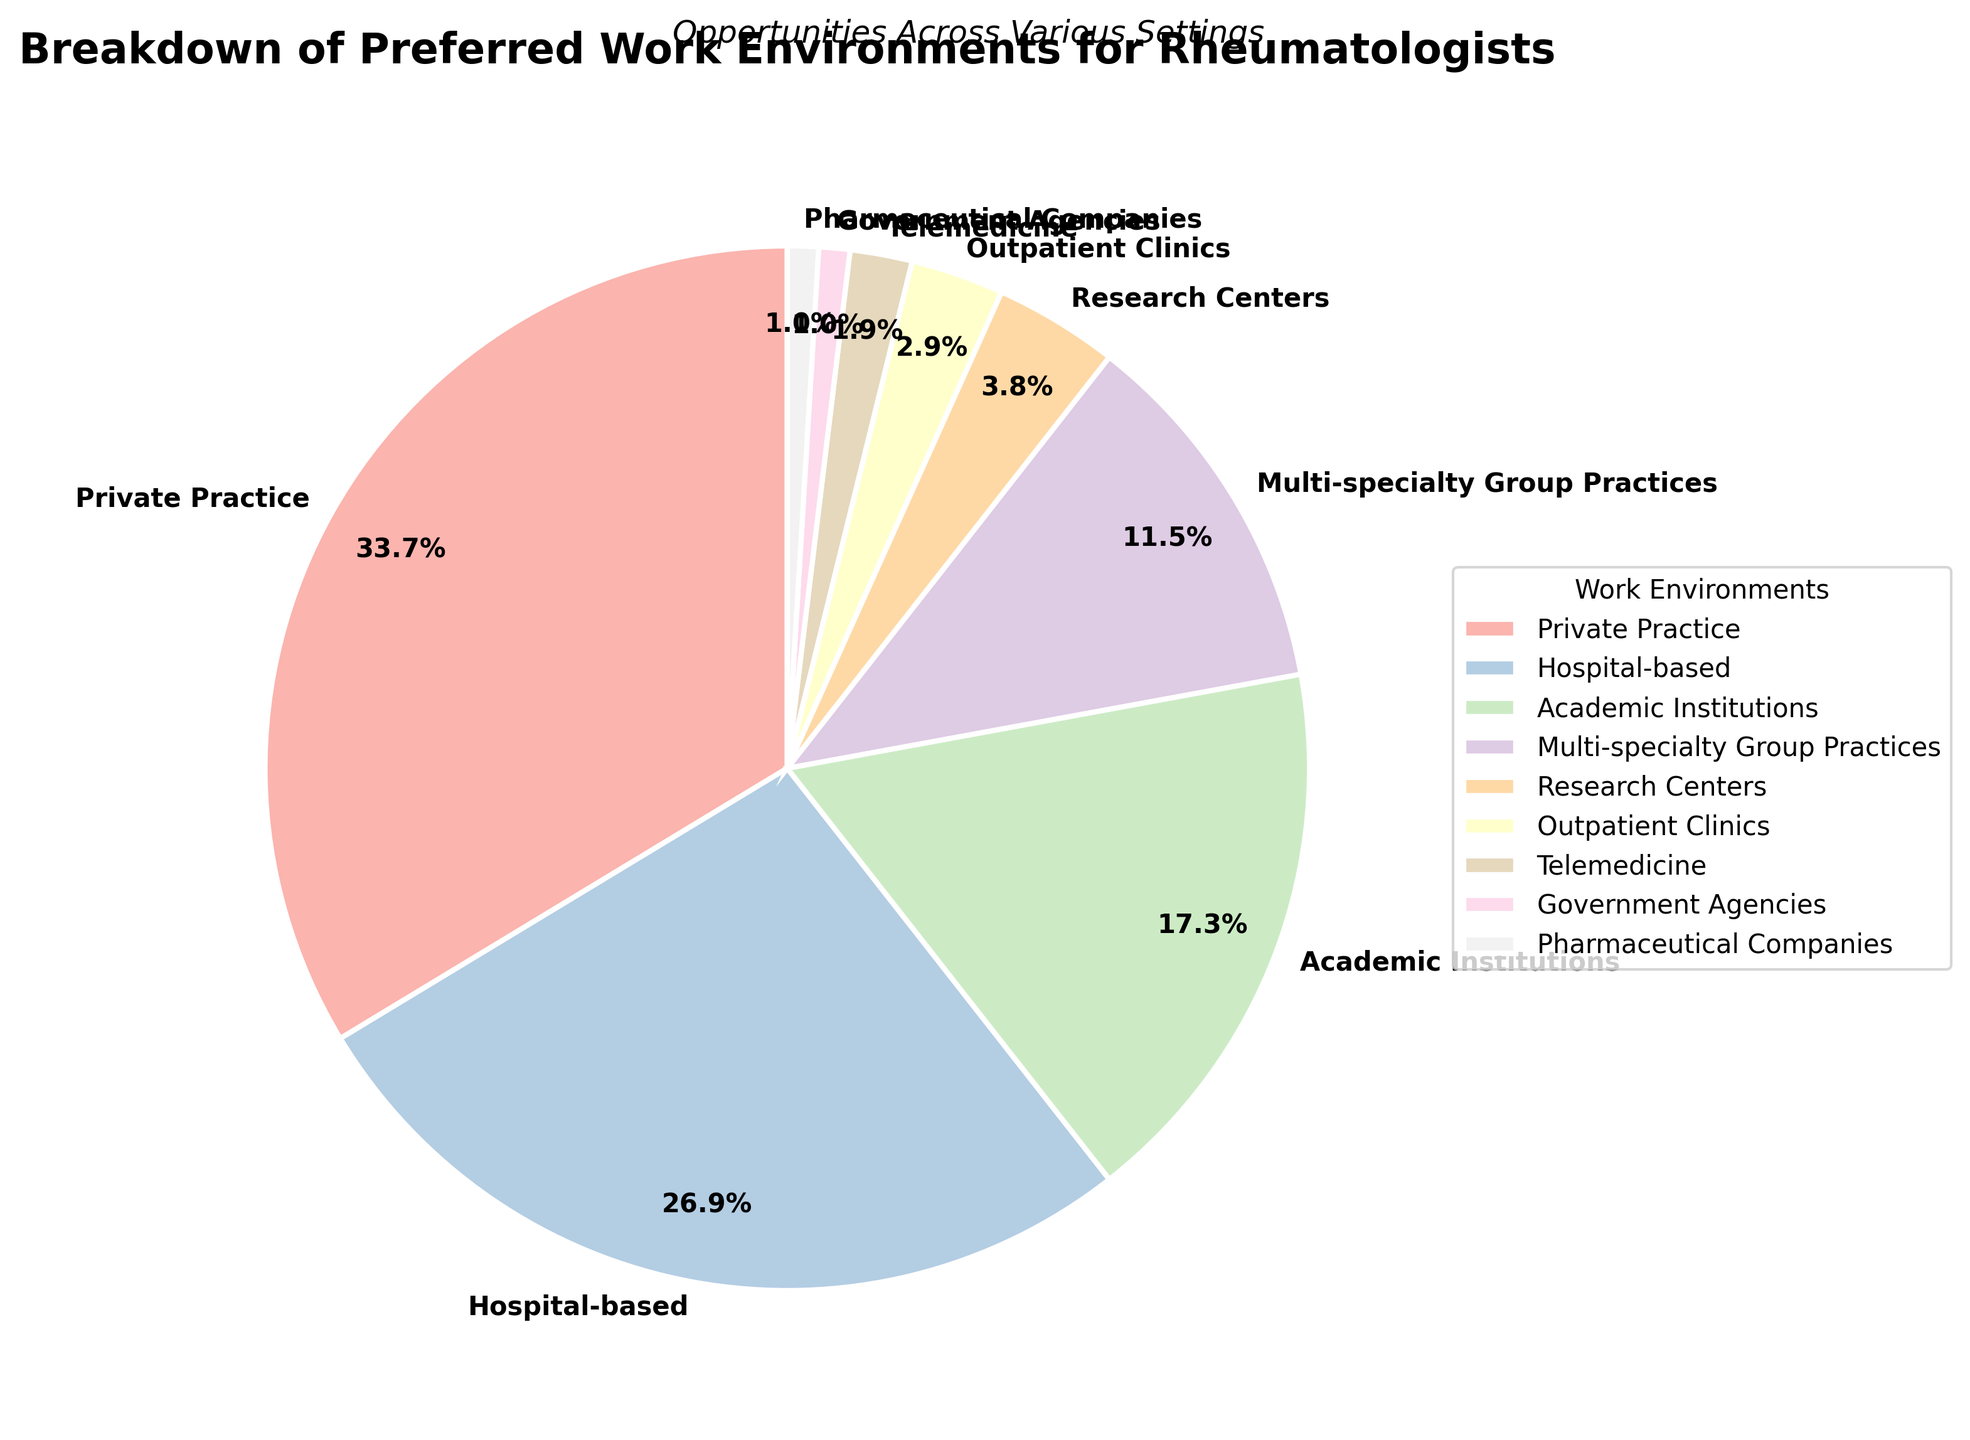What is the most preferred work environment among rheumatologists? The pie chart shows the largest slice corresponding to "Private Practice," indicating it as the most preferred.
Answer: Private Practice How many work environments have a preference percentage of less than 5%? By examining the pie chart, we see "Research Centers," "Outpatient Clinics," "Telemedicine," "Government Agencies," and "Pharmaceutical Companies" each have a preference percentage less than 5%. These total to five environments.
Answer: 5 Which work environment has the smallest percentage of preference among rheumatologists? The smallest slice in the pie chart corresponds to "Government Agencies" and "Pharmaceutical Companies," each marked with a 1% preference.
Answer: Government Agencies and Pharmaceutical Companies What is the total percentage of preference for non-hospital-based environments? By excluding "Hospital-based" (28%), sum the percentages of all other environments: 35% (Private Practice) + 18% (Academic Institutions) + 12% (Multi-specialty Group Practices) + 4% (Research Centers) + 3% (Outpatient Clinics) + 2% (Telemedicine) + 1% (Government Agencies) + 1% (Pharmaceutical Companies) = 76%.
Answer: 76% Which work environment is preferred more, Academic Institutions or Multi-specialty Group Practices, and by how much? Comparing the slices for "Academic Institutions" (18%) and "Multi-specialty Group Practices" (12%), "Academic Institutions" is preferred more. The difference is 18% - 12% = 6%.
Answer: Academic Institutions by 6% What percentage do Hospital-based and Private Practice combined represent? Add the percentage of "Hospital-based" (28%) and "Private Practice" (35%): 28% + 35% = 63%.
Answer: 63% What is the ratio of rheumatologists preferring Private Practice to those preferring Research Centers? The chart shows 35% for Private Practice and 4% for Research Centers. The ratio is 35:4, which simplifies to 8.75:1.
Answer: 8.75:1 Which work environment segment is color-coded with the first color in the Pastel1 colormap? The first color in the Pastel1 colormap is typically associated with the first item in the data, which is "Private Practice."
Answer: Private Practice How much more preferred is Multi-specialty Group Practices compared to Outpatient Clinics in terms of percentage points? Compare percentages: 12% (Multi-specialty Group Practices) - 3% (Outpatient Clinics) = 9%.
Answer: 9% If you combine the percentages for all the least preferred environments (with preference percentage of 3% or lower), what total percentage do they represent? Sum the percentages for "Outpatient Clinics" (3%), "Telemedicine" (2%), "Government Agencies" (1%), and "Pharmaceutical Companies" (1%): 3% + 2% + 1% + 1% = 7%.
Answer: 7% 